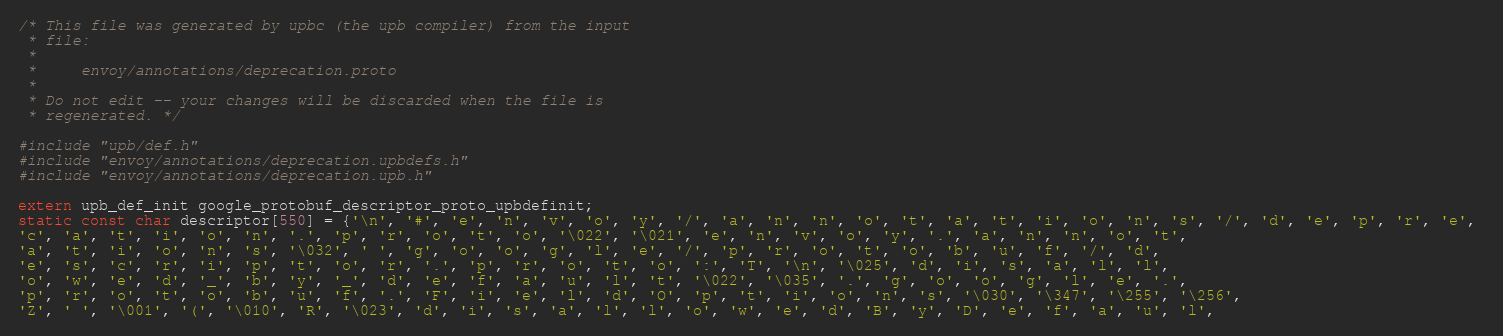<code> <loc_0><loc_0><loc_500><loc_500><_C_>/* This file was generated by upbc (the upb compiler) from the input
 * file:
 *
 *     envoy/annotations/deprecation.proto
 *
 * Do not edit -- your changes will be discarded when the file is
 * regenerated. */

#include "upb/def.h"
#include "envoy/annotations/deprecation.upbdefs.h"
#include "envoy/annotations/deprecation.upb.h"

extern upb_def_init google_protobuf_descriptor_proto_upbdefinit;
static const char descriptor[550] = {'\n', '#', 'e', 'n', 'v', 'o', 'y', '/', 'a', 'n', 'n', 'o', 't', 'a', 't', 'i', 'o', 'n', 's', '/', 'd', 'e', 'p', 'r', 'e', 
'c', 'a', 't', 'i', 'o', 'n', '.', 'p', 'r', 'o', 't', 'o', '\022', '\021', 'e', 'n', 'v', 'o', 'y', '.', 'a', 'n', 'n', 'o', 't', 
'a', 't', 'i', 'o', 'n', 's', '\032', ' ', 'g', 'o', 'o', 'g', 'l', 'e', '/', 'p', 'r', 'o', 't', 'o', 'b', 'u', 'f', '/', 'd', 
'e', 's', 'c', 'r', 'i', 'p', 't', 'o', 'r', '.', 'p', 'r', 'o', 't', 'o', ':', 'T', '\n', '\025', 'd', 'i', 's', 'a', 'l', 'l', 
'o', 'w', 'e', 'd', '_', 'b', 'y', '_', 'd', 'e', 'f', 'a', 'u', 'l', 't', '\022', '\035', '.', 'g', 'o', 'o', 'g', 'l', 'e', '.', 
'p', 'r', 'o', 't', 'o', 'b', 'u', 'f', '.', 'F', 'i', 'e', 'l', 'd', 'O', 'p', 't', 'i', 'o', 'n', 's', '\030', '\347', '\255', '\256', 
'Z', ' ', '\001', '(', '\010', 'R', '\023', 'd', 'i', 's', 'a', 'l', 'l', 'o', 'w', 'e', 'd', 'B', 'y', 'D', 'e', 'f', 'a', 'u', 'l', </code> 